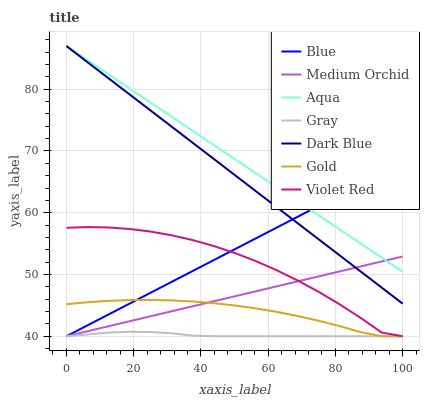Does Gray have the minimum area under the curve?
Answer yes or no. Yes. Does Aqua have the maximum area under the curve?
Answer yes or no. Yes. Does Violet Red have the minimum area under the curve?
Answer yes or no. No. Does Violet Red have the maximum area under the curve?
Answer yes or no. No. Is Dark Blue the smoothest?
Answer yes or no. Yes. Is Violet Red the roughest?
Answer yes or no. Yes. Is Gray the smoothest?
Answer yes or no. No. Is Gray the roughest?
Answer yes or no. No. Does Blue have the lowest value?
Answer yes or no. Yes. Does Aqua have the lowest value?
Answer yes or no. No. Does Dark Blue have the highest value?
Answer yes or no. Yes. Does Violet Red have the highest value?
Answer yes or no. No. Is Gray less than Aqua?
Answer yes or no. Yes. Is Aqua greater than Violet Red?
Answer yes or no. Yes. Does Blue intersect Violet Red?
Answer yes or no. Yes. Is Blue less than Violet Red?
Answer yes or no. No. Is Blue greater than Violet Red?
Answer yes or no. No. Does Gray intersect Aqua?
Answer yes or no. No. 